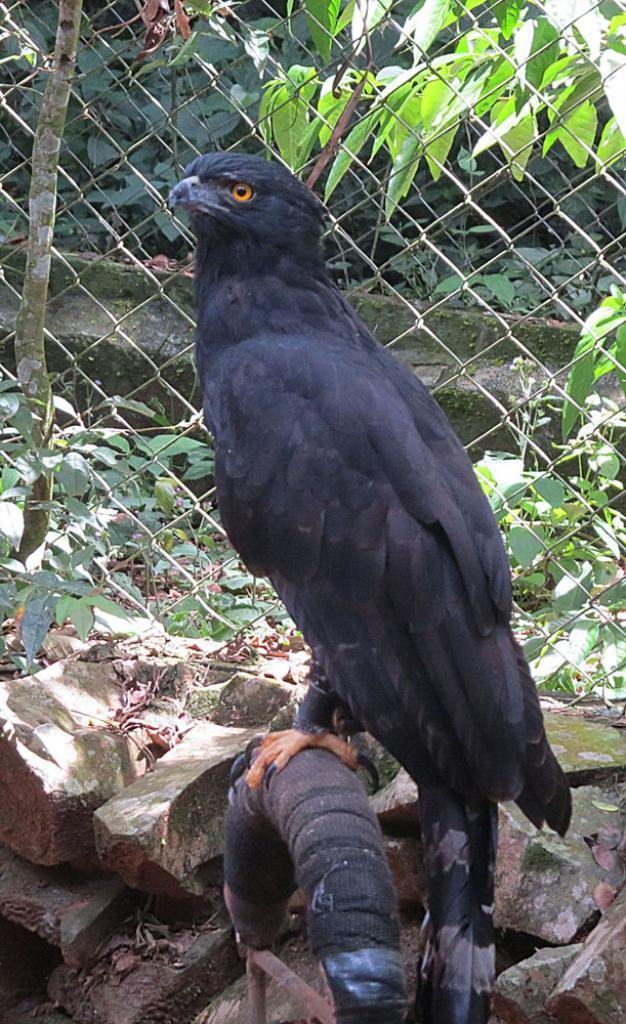What type of animal can be seen in the image? There is a bird in the image. What celestial objects are visible at the bottom of the image? Stars are visible at the bottom of the image. What type of vegetation is present in the image? There are leaves and plants in the image. What type of structure can be seen in the image? There is a fence visible in the image. How many cherries are hanging from the fence in the image? There are no cherries present in the image; the image only features a bird, stars, leaves, plants, and a fence. 